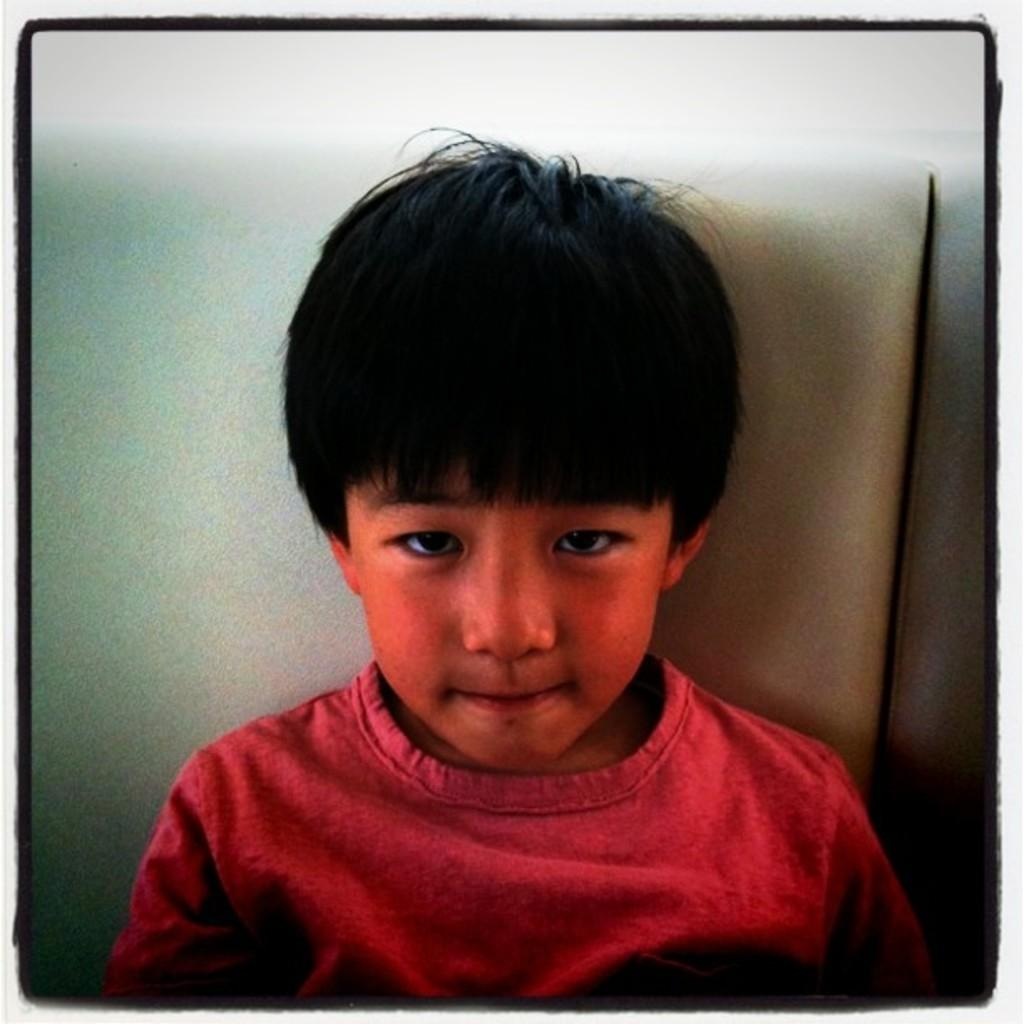Who or what is the main subject in the image? There is a child in the image. What is the child wearing? The child is wearing a red t-shirt. Where is the child sitting? The child is sitting on a seat. Can you describe the color of the seat? The seat is cream and white in color. What is the color of the background in the image? The background of the image is white. Can you see any poisonous creatures in the image? There are no poisonous creatures present in the image. What type of ocean can be seen in the background of the image? There is no ocean visible in the image; the background is white. 